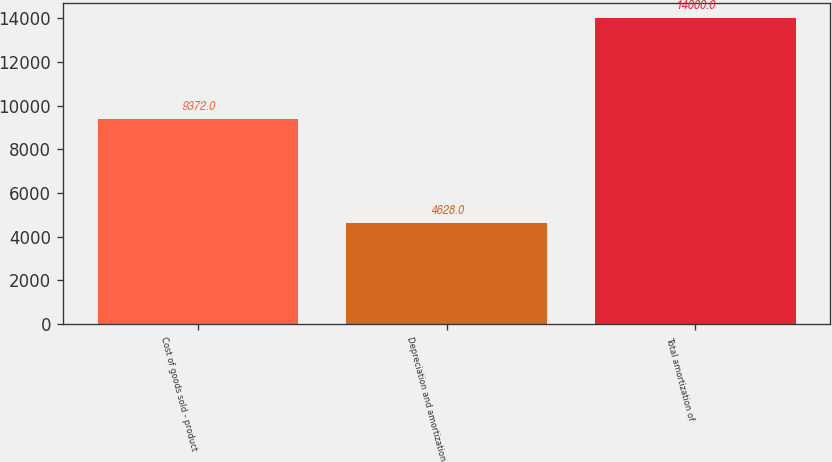Convert chart. <chart><loc_0><loc_0><loc_500><loc_500><bar_chart><fcel>Cost of goods sold - product<fcel>Depreciation and amortization<fcel>Total amortization of<nl><fcel>9372<fcel>4628<fcel>14000<nl></chart> 